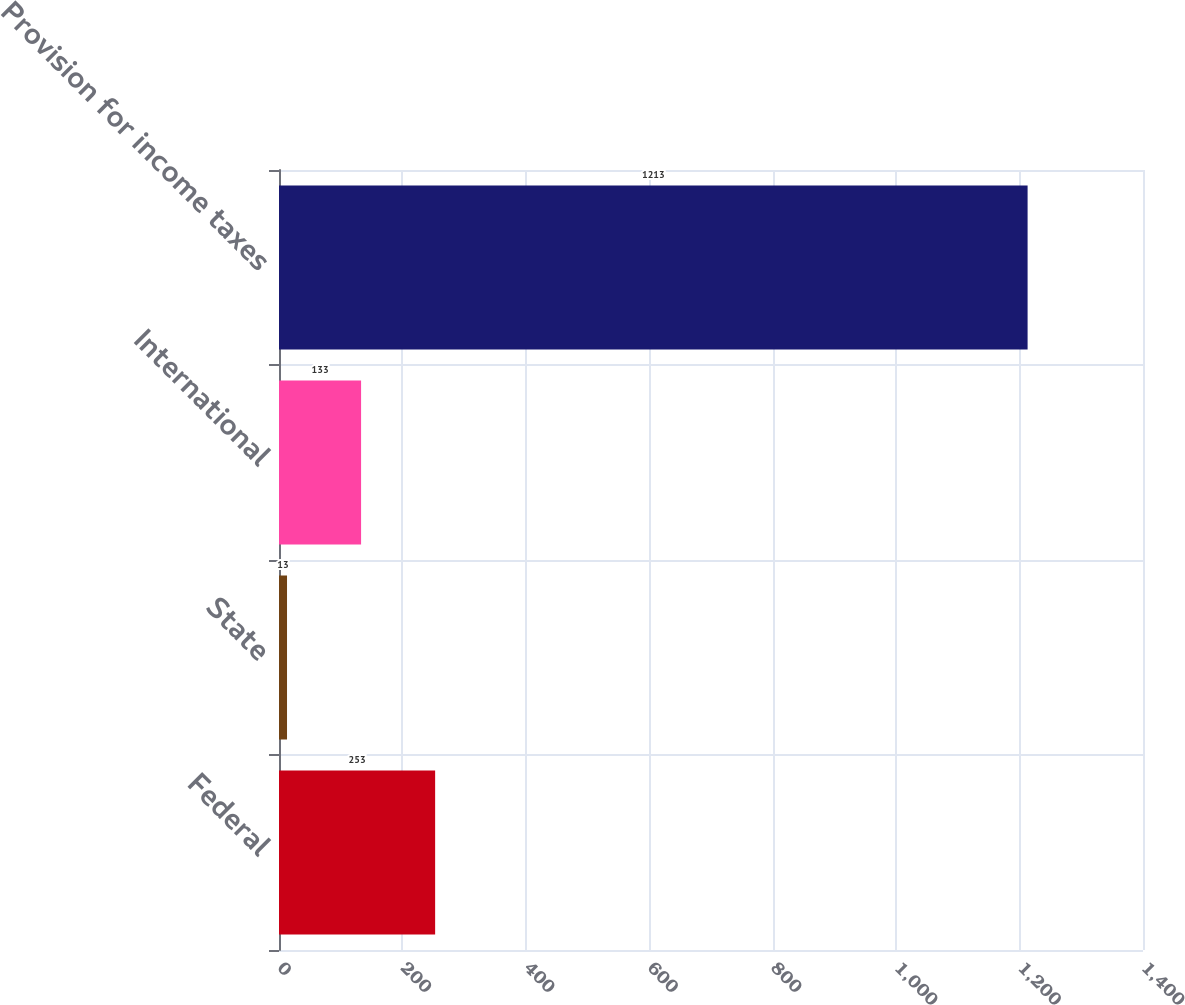<chart> <loc_0><loc_0><loc_500><loc_500><bar_chart><fcel>Federal<fcel>State<fcel>International<fcel>Provision for income taxes<nl><fcel>253<fcel>13<fcel>133<fcel>1213<nl></chart> 